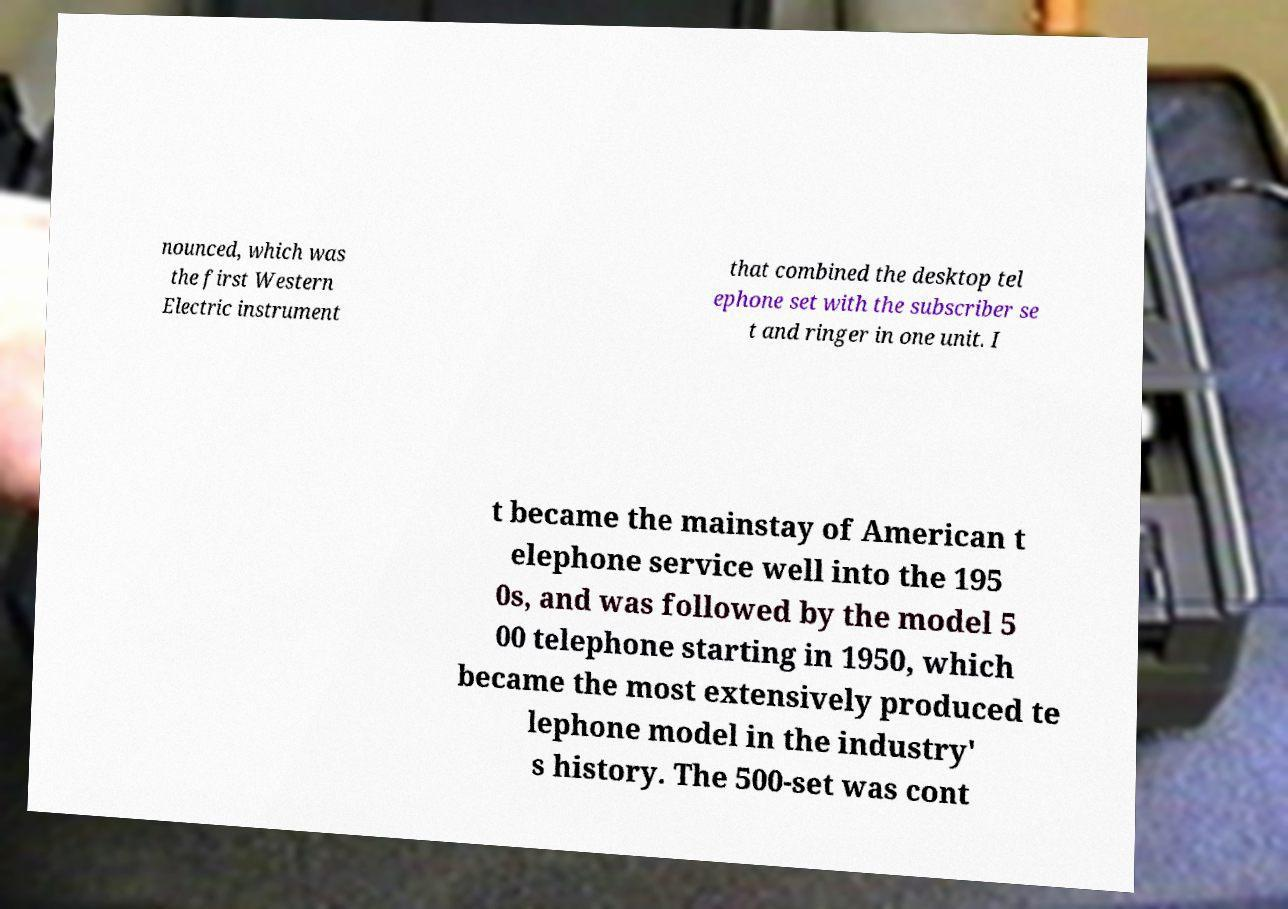Please identify and transcribe the text found in this image. nounced, which was the first Western Electric instrument that combined the desktop tel ephone set with the subscriber se t and ringer in one unit. I t became the mainstay of American t elephone service well into the 195 0s, and was followed by the model 5 00 telephone starting in 1950, which became the most extensively produced te lephone model in the industry' s history. The 500-set was cont 